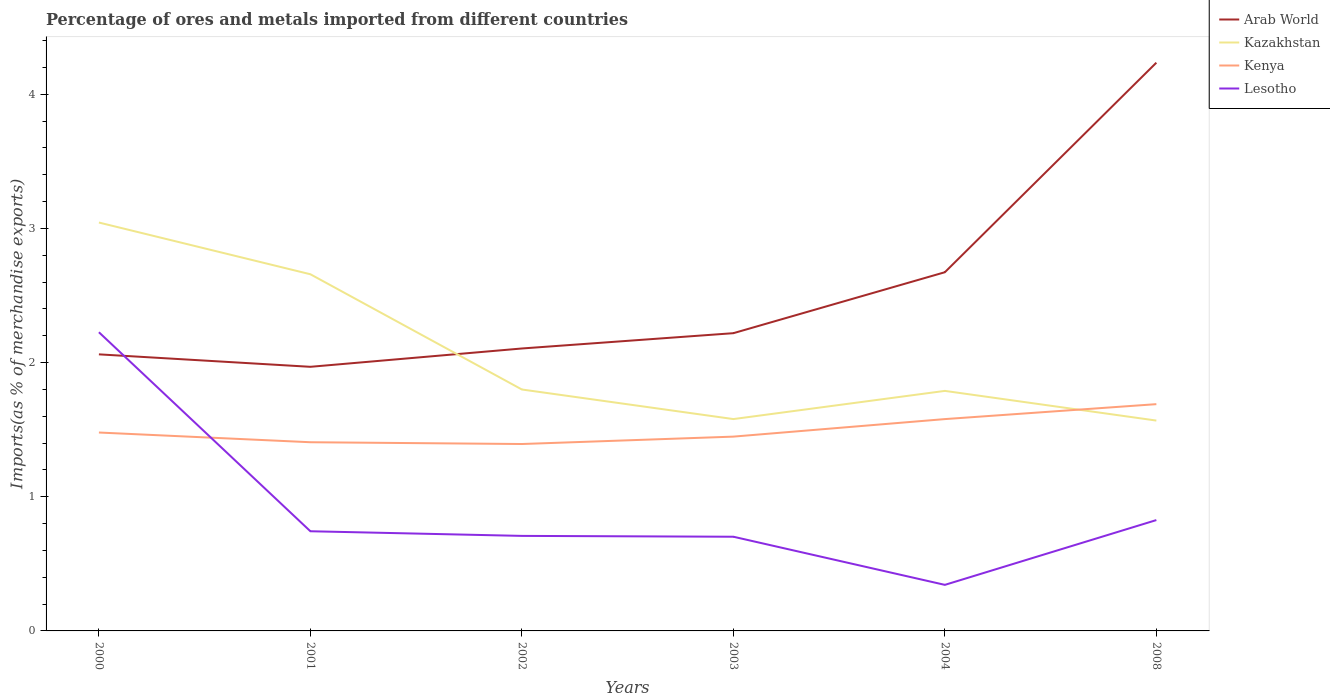Is the number of lines equal to the number of legend labels?
Give a very brief answer. Yes. Across all years, what is the maximum percentage of imports to different countries in Lesotho?
Provide a succinct answer. 0.34. In which year was the percentage of imports to different countries in Lesotho maximum?
Give a very brief answer. 2004. What is the total percentage of imports to different countries in Kazakhstan in the graph?
Make the answer very short. 1.47. What is the difference between the highest and the second highest percentage of imports to different countries in Arab World?
Your response must be concise. 2.27. How many years are there in the graph?
Keep it short and to the point. 6. Does the graph contain any zero values?
Ensure brevity in your answer.  No. Does the graph contain grids?
Ensure brevity in your answer.  No. Where does the legend appear in the graph?
Provide a short and direct response. Top right. How many legend labels are there?
Ensure brevity in your answer.  4. How are the legend labels stacked?
Offer a very short reply. Vertical. What is the title of the graph?
Provide a short and direct response. Percentage of ores and metals imported from different countries. Does "Madagascar" appear as one of the legend labels in the graph?
Keep it short and to the point. No. What is the label or title of the Y-axis?
Give a very brief answer. Imports(as % of merchandise exports). What is the Imports(as % of merchandise exports) of Arab World in 2000?
Give a very brief answer. 2.06. What is the Imports(as % of merchandise exports) of Kazakhstan in 2000?
Offer a very short reply. 3.04. What is the Imports(as % of merchandise exports) of Kenya in 2000?
Provide a short and direct response. 1.48. What is the Imports(as % of merchandise exports) in Lesotho in 2000?
Your response must be concise. 2.23. What is the Imports(as % of merchandise exports) of Arab World in 2001?
Ensure brevity in your answer.  1.97. What is the Imports(as % of merchandise exports) in Kazakhstan in 2001?
Your response must be concise. 2.66. What is the Imports(as % of merchandise exports) in Kenya in 2001?
Keep it short and to the point. 1.41. What is the Imports(as % of merchandise exports) of Lesotho in 2001?
Keep it short and to the point. 0.74. What is the Imports(as % of merchandise exports) of Arab World in 2002?
Keep it short and to the point. 2.11. What is the Imports(as % of merchandise exports) in Kazakhstan in 2002?
Your answer should be very brief. 1.8. What is the Imports(as % of merchandise exports) of Kenya in 2002?
Provide a succinct answer. 1.39. What is the Imports(as % of merchandise exports) of Lesotho in 2002?
Your answer should be very brief. 0.71. What is the Imports(as % of merchandise exports) of Arab World in 2003?
Keep it short and to the point. 2.22. What is the Imports(as % of merchandise exports) in Kazakhstan in 2003?
Your answer should be compact. 1.58. What is the Imports(as % of merchandise exports) of Kenya in 2003?
Make the answer very short. 1.45. What is the Imports(as % of merchandise exports) in Lesotho in 2003?
Ensure brevity in your answer.  0.7. What is the Imports(as % of merchandise exports) in Arab World in 2004?
Provide a short and direct response. 2.67. What is the Imports(as % of merchandise exports) of Kazakhstan in 2004?
Offer a very short reply. 1.79. What is the Imports(as % of merchandise exports) of Kenya in 2004?
Your answer should be compact. 1.58. What is the Imports(as % of merchandise exports) of Lesotho in 2004?
Offer a terse response. 0.34. What is the Imports(as % of merchandise exports) of Arab World in 2008?
Offer a terse response. 4.24. What is the Imports(as % of merchandise exports) of Kazakhstan in 2008?
Offer a terse response. 1.57. What is the Imports(as % of merchandise exports) of Kenya in 2008?
Your answer should be compact. 1.69. What is the Imports(as % of merchandise exports) of Lesotho in 2008?
Ensure brevity in your answer.  0.83. Across all years, what is the maximum Imports(as % of merchandise exports) of Arab World?
Offer a terse response. 4.24. Across all years, what is the maximum Imports(as % of merchandise exports) in Kazakhstan?
Offer a very short reply. 3.04. Across all years, what is the maximum Imports(as % of merchandise exports) of Kenya?
Give a very brief answer. 1.69. Across all years, what is the maximum Imports(as % of merchandise exports) in Lesotho?
Your answer should be compact. 2.23. Across all years, what is the minimum Imports(as % of merchandise exports) of Arab World?
Offer a very short reply. 1.97. Across all years, what is the minimum Imports(as % of merchandise exports) in Kazakhstan?
Keep it short and to the point. 1.57. Across all years, what is the minimum Imports(as % of merchandise exports) in Kenya?
Your answer should be compact. 1.39. Across all years, what is the minimum Imports(as % of merchandise exports) in Lesotho?
Offer a very short reply. 0.34. What is the total Imports(as % of merchandise exports) of Arab World in the graph?
Give a very brief answer. 15.27. What is the total Imports(as % of merchandise exports) in Kazakhstan in the graph?
Your response must be concise. 12.44. What is the total Imports(as % of merchandise exports) in Kenya in the graph?
Provide a short and direct response. 9. What is the total Imports(as % of merchandise exports) in Lesotho in the graph?
Your response must be concise. 5.55. What is the difference between the Imports(as % of merchandise exports) of Arab World in 2000 and that in 2001?
Ensure brevity in your answer.  0.09. What is the difference between the Imports(as % of merchandise exports) in Kazakhstan in 2000 and that in 2001?
Keep it short and to the point. 0.39. What is the difference between the Imports(as % of merchandise exports) in Kenya in 2000 and that in 2001?
Offer a terse response. 0.07. What is the difference between the Imports(as % of merchandise exports) of Lesotho in 2000 and that in 2001?
Ensure brevity in your answer.  1.48. What is the difference between the Imports(as % of merchandise exports) in Arab World in 2000 and that in 2002?
Keep it short and to the point. -0.04. What is the difference between the Imports(as % of merchandise exports) in Kazakhstan in 2000 and that in 2002?
Make the answer very short. 1.24. What is the difference between the Imports(as % of merchandise exports) of Kenya in 2000 and that in 2002?
Offer a terse response. 0.09. What is the difference between the Imports(as % of merchandise exports) of Lesotho in 2000 and that in 2002?
Your response must be concise. 1.52. What is the difference between the Imports(as % of merchandise exports) in Arab World in 2000 and that in 2003?
Keep it short and to the point. -0.16. What is the difference between the Imports(as % of merchandise exports) in Kazakhstan in 2000 and that in 2003?
Your answer should be very brief. 1.47. What is the difference between the Imports(as % of merchandise exports) in Kenya in 2000 and that in 2003?
Provide a succinct answer. 0.03. What is the difference between the Imports(as % of merchandise exports) in Lesotho in 2000 and that in 2003?
Offer a very short reply. 1.52. What is the difference between the Imports(as % of merchandise exports) of Arab World in 2000 and that in 2004?
Make the answer very short. -0.61. What is the difference between the Imports(as % of merchandise exports) in Kazakhstan in 2000 and that in 2004?
Offer a very short reply. 1.25. What is the difference between the Imports(as % of merchandise exports) of Kenya in 2000 and that in 2004?
Make the answer very short. -0.1. What is the difference between the Imports(as % of merchandise exports) of Lesotho in 2000 and that in 2004?
Offer a terse response. 1.88. What is the difference between the Imports(as % of merchandise exports) of Arab World in 2000 and that in 2008?
Your answer should be very brief. -2.17. What is the difference between the Imports(as % of merchandise exports) of Kazakhstan in 2000 and that in 2008?
Your answer should be very brief. 1.48. What is the difference between the Imports(as % of merchandise exports) of Kenya in 2000 and that in 2008?
Your answer should be compact. -0.21. What is the difference between the Imports(as % of merchandise exports) in Lesotho in 2000 and that in 2008?
Provide a short and direct response. 1.4. What is the difference between the Imports(as % of merchandise exports) in Arab World in 2001 and that in 2002?
Make the answer very short. -0.14. What is the difference between the Imports(as % of merchandise exports) in Kazakhstan in 2001 and that in 2002?
Provide a short and direct response. 0.86. What is the difference between the Imports(as % of merchandise exports) in Kenya in 2001 and that in 2002?
Your answer should be compact. 0.01. What is the difference between the Imports(as % of merchandise exports) in Lesotho in 2001 and that in 2002?
Offer a terse response. 0.03. What is the difference between the Imports(as % of merchandise exports) of Arab World in 2001 and that in 2003?
Offer a very short reply. -0.25. What is the difference between the Imports(as % of merchandise exports) of Kazakhstan in 2001 and that in 2003?
Provide a succinct answer. 1.08. What is the difference between the Imports(as % of merchandise exports) of Kenya in 2001 and that in 2003?
Keep it short and to the point. -0.04. What is the difference between the Imports(as % of merchandise exports) of Lesotho in 2001 and that in 2003?
Keep it short and to the point. 0.04. What is the difference between the Imports(as % of merchandise exports) of Arab World in 2001 and that in 2004?
Provide a short and direct response. -0.71. What is the difference between the Imports(as % of merchandise exports) in Kazakhstan in 2001 and that in 2004?
Give a very brief answer. 0.87. What is the difference between the Imports(as % of merchandise exports) of Kenya in 2001 and that in 2004?
Your response must be concise. -0.17. What is the difference between the Imports(as % of merchandise exports) in Lesotho in 2001 and that in 2004?
Your answer should be compact. 0.4. What is the difference between the Imports(as % of merchandise exports) of Arab World in 2001 and that in 2008?
Your answer should be compact. -2.27. What is the difference between the Imports(as % of merchandise exports) in Kazakhstan in 2001 and that in 2008?
Provide a short and direct response. 1.09. What is the difference between the Imports(as % of merchandise exports) in Kenya in 2001 and that in 2008?
Give a very brief answer. -0.28. What is the difference between the Imports(as % of merchandise exports) of Lesotho in 2001 and that in 2008?
Your answer should be compact. -0.08. What is the difference between the Imports(as % of merchandise exports) in Arab World in 2002 and that in 2003?
Your response must be concise. -0.11. What is the difference between the Imports(as % of merchandise exports) of Kazakhstan in 2002 and that in 2003?
Provide a succinct answer. 0.22. What is the difference between the Imports(as % of merchandise exports) in Kenya in 2002 and that in 2003?
Your answer should be compact. -0.06. What is the difference between the Imports(as % of merchandise exports) of Lesotho in 2002 and that in 2003?
Offer a terse response. 0.01. What is the difference between the Imports(as % of merchandise exports) of Arab World in 2002 and that in 2004?
Offer a very short reply. -0.57. What is the difference between the Imports(as % of merchandise exports) of Kazakhstan in 2002 and that in 2004?
Provide a succinct answer. 0.01. What is the difference between the Imports(as % of merchandise exports) of Kenya in 2002 and that in 2004?
Provide a short and direct response. -0.19. What is the difference between the Imports(as % of merchandise exports) of Lesotho in 2002 and that in 2004?
Provide a short and direct response. 0.36. What is the difference between the Imports(as % of merchandise exports) of Arab World in 2002 and that in 2008?
Your response must be concise. -2.13. What is the difference between the Imports(as % of merchandise exports) in Kazakhstan in 2002 and that in 2008?
Make the answer very short. 0.23. What is the difference between the Imports(as % of merchandise exports) in Kenya in 2002 and that in 2008?
Your answer should be very brief. -0.3. What is the difference between the Imports(as % of merchandise exports) in Lesotho in 2002 and that in 2008?
Keep it short and to the point. -0.12. What is the difference between the Imports(as % of merchandise exports) in Arab World in 2003 and that in 2004?
Your answer should be very brief. -0.45. What is the difference between the Imports(as % of merchandise exports) in Kazakhstan in 2003 and that in 2004?
Ensure brevity in your answer.  -0.21. What is the difference between the Imports(as % of merchandise exports) of Kenya in 2003 and that in 2004?
Ensure brevity in your answer.  -0.13. What is the difference between the Imports(as % of merchandise exports) of Lesotho in 2003 and that in 2004?
Provide a succinct answer. 0.36. What is the difference between the Imports(as % of merchandise exports) in Arab World in 2003 and that in 2008?
Your answer should be very brief. -2.02. What is the difference between the Imports(as % of merchandise exports) in Kazakhstan in 2003 and that in 2008?
Offer a terse response. 0.01. What is the difference between the Imports(as % of merchandise exports) of Kenya in 2003 and that in 2008?
Your response must be concise. -0.24. What is the difference between the Imports(as % of merchandise exports) of Lesotho in 2003 and that in 2008?
Offer a terse response. -0.12. What is the difference between the Imports(as % of merchandise exports) in Arab World in 2004 and that in 2008?
Keep it short and to the point. -1.56. What is the difference between the Imports(as % of merchandise exports) in Kazakhstan in 2004 and that in 2008?
Provide a succinct answer. 0.22. What is the difference between the Imports(as % of merchandise exports) of Kenya in 2004 and that in 2008?
Offer a very short reply. -0.11. What is the difference between the Imports(as % of merchandise exports) in Lesotho in 2004 and that in 2008?
Your answer should be compact. -0.48. What is the difference between the Imports(as % of merchandise exports) of Arab World in 2000 and the Imports(as % of merchandise exports) of Kazakhstan in 2001?
Offer a terse response. -0.6. What is the difference between the Imports(as % of merchandise exports) of Arab World in 2000 and the Imports(as % of merchandise exports) of Kenya in 2001?
Offer a terse response. 0.66. What is the difference between the Imports(as % of merchandise exports) in Arab World in 2000 and the Imports(as % of merchandise exports) in Lesotho in 2001?
Offer a very short reply. 1.32. What is the difference between the Imports(as % of merchandise exports) in Kazakhstan in 2000 and the Imports(as % of merchandise exports) in Kenya in 2001?
Ensure brevity in your answer.  1.64. What is the difference between the Imports(as % of merchandise exports) of Kazakhstan in 2000 and the Imports(as % of merchandise exports) of Lesotho in 2001?
Your answer should be very brief. 2.3. What is the difference between the Imports(as % of merchandise exports) in Kenya in 2000 and the Imports(as % of merchandise exports) in Lesotho in 2001?
Make the answer very short. 0.74. What is the difference between the Imports(as % of merchandise exports) of Arab World in 2000 and the Imports(as % of merchandise exports) of Kazakhstan in 2002?
Offer a terse response. 0.26. What is the difference between the Imports(as % of merchandise exports) of Arab World in 2000 and the Imports(as % of merchandise exports) of Kenya in 2002?
Offer a very short reply. 0.67. What is the difference between the Imports(as % of merchandise exports) of Arab World in 2000 and the Imports(as % of merchandise exports) of Lesotho in 2002?
Make the answer very short. 1.35. What is the difference between the Imports(as % of merchandise exports) of Kazakhstan in 2000 and the Imports(as % of merchandise exports) of Kenya in 2002?
Your answer should be compact. 1.65. What is the difference between the Imports(as % of merchandise exports) of Kazakhstan in 2000 and the Imports(as % of merchandise exports) of Lesotho in 2002?
Give a very brief answer. 2.34. What is the difference between the Imports(as % of merchandise exports) in Kenya in 2000 and the Imports(as % of merchandise exports) in Lesotho in 2002?
Offer a very short reply. 0.77. What is the difference between the Imports(as % of merchandise exports) of Arab World in 2000 and the Imports(as % of merchandise exports) of Kazakhstan in 2003?
Offer a very short reply. 0.48. What is the difference between the Imports(as % of merchandise exports) in Arab World in 2000 and the Imports(as % of merchandise exports) in Kenya in 2003?
Make the answer very short. 0.61. What is the difference between the Imports(as % of merchandise exports) in Arab World in 2000 and the Imports(as % of merchandise exports) in Lesotho in 2003?
Provide a short and direct response. 1.36. What is the difference between the Imports(as % of merchandise exports) in Kazakhstan in 2000 and the Imports(as % of merchandise exports) in Kenya in 2003?
Your answer should be very brief. 1.6. What is the difference between the Imports(as % of merchandise exports) of Kazakhstan in 2000 and the Imports(as % of merchandise exports) of Lesotho in 2003?
Your response must be concise. 2.34. What is the difference between the Imports(as % of merchandise exports) of Kenya in 2000 and the Imports(as % of merchandise exports) of Lesotho in 2003?
Offer a terse response. 0.78. What is the difference between the Imports(as % of merchandise exports) of Arab World in 2000 and the Imports(as % of merchandise exports) of Kazakhstan in 2004?
Your response must be concise. 0.27. What is the difference between the Imports(as % of merchandise exports) in Arab World in 2000 and the Imports(as % of merchandise exports) in Kenya in 2004?
Offer a terse response. 0.48. What is the difference between the Imports(as % of merchandise exports) of Arab World in 2000 and the Imports(as % of merchandise exports) of Lesotho in 2004?
Offer a terse response. 1.72. What is the difference between the Imports(as % of merchandise exports) in Kazakhstan in 2000 and the Imports(as % of merchandise exports) in Kenya in 2004?
Your answer should be very brief. 1.47. What is the difference between the Imports(as % of merchandise exports) in Kazakhstan in 2000 and the Imports(as % of merchandise exports) in Lesotho in 2004?
Offer a very short reply. 2.7. What is the difference between the Imports(as % of merchandise exports) of Kenya in 2000 and the Imports(as % of merchandise exports) of Lesotho in 2004?
Offer a very short reply. 1.14. What is the difference between the Imports(as % of merchandise exports) of Arab World in 2000 and the Imports(as % of merchandise exports) of Kazakhstan in 2008?
Ensure brevity in your answer.  0.49. What is the difference between the Imports(as % of merchandise exports) in Arab World in 2000 and the Imports(as % of merchandise exports) in Kenya in 2008?
Ensure brevity in your answer.  0.37. What is the difference between the Imports(as % of merchandise exports) of Arab World in 2000 and the Imports(as % of merchandise exports) of Lesotho in 2008?
Make the answer very short. 1.24. What is the difference between the Imports(as % of merchandise exports) of Kazakhstan in 2000 and the Imports(as % of merchandise exports) of Kenya in 2008?
Your response must be concise. 1.35. What is the difference between the Imports(as % of merchandise exports) of Kazakhstan in 2000 and the Imports(as % of merchandise exports) of Lesotho in 2008?
Your response must be concise. 2.22. What is the difference between the Imports(as % of merchandise exports) in Kenya in 2000 and the Imports(as % of merchandise exports) in Lesotho in 2008?
Give a very brief answer. 0.65. What is the difference between the Imports(as % of merchandise exports) in Arab World in 2001 and the Imports(as % of merchandise exports) in Kazakhstan in 2002?
Provide a succinct answer. 0.17. What is the difference between the Imports(as % of merchandise exports) in Arab World in 2001 and the Imports(as % of merchandise exports) in Kenya in 2002?
Your answer should be very brief. 0.58. What is the difference between the Imports(as % of merchandise exports) in Arab World in 2001 and the Imports(as % of merchandise exports) in Lesotho in 2002?
Keep it short and to the point. 1.26. What is the difference between the Imports(as % of merchandise exports) in Kazakhstan in 2001 and the Imports(as % of merchandise exports) in Kenya in 2002?
Give a very brief answer. 1.27. What is the difference between the Imports(as % of merchandise exports) in Kazakhstan in 2001 and the Imports(as % of merchandise exports) in Lesotho in 2002?
Provide a succinct answer. 1.95. What is the difference between the Imports(as % of merchandise exports) of Kenya in 2001 and the Imports(as % of merchandise exports) of Lesotho in 2002?
Offer a very short reply. 0.7. What is the difference between the Imports(as % of merchandise exports) in Arab World in 2001 and the Imports(as % of merchandise exports) in Kazakhstan in 2003?
Keep it short and to the point. 0.39. What is the difference between the Imports(as % of merchandise exports) in Arab World in 2001 and the Imports(as % of merchandise exports) in Kenya in 2003?
Offer a terse response. 0.52. What is the difference between the Imports(as % of merchandise exports) in Arab World in 2001 and the Imports(as % of merchandise exports) in Lesotho in 2003?
Offer a terse response. 1.27. What is the difference between the Imports(as % of merchandise exports) of Kazakhstan in 2001 and the Imports(as % of merchandise exports) of Kenya in 2003?
Ensure brevity in your answer.  1.21. What is the difference between the Imports(as % of merchandise exports) in Kazakhstan in 2001 and the Imports(as % of merchandise exports) in Lesotho in 2003?
Your answer should be very brief. 1.96. What is the difference between the Imports(as % of merchandise exports) in Kenya in 2001 and the Imports(as % of merchandise exports) in Lesotho in 2003?
Ensure brevity in your answer.  0.7. What is the difference between the Imports(as % of merchandise exports) of Arab World in 2001 and the Imports(as % of merchandise exports) of Kazakhstan in 2004?
Provide a short and direct response. 0.18. What is the difference between the Imports(as % of merchandise exports) of Arab World in 2001 and the Imports(as % of merchandise exports) of Kenya in 2004?
Offer a terse response. 0.39. What is the difference between the Imports(as % of merchandise exports) of Arab World in 2001 and the Imports(as % of merchandise exports) of Lesotho in 2004?
Offer a terse response. 1.63. What is the difference between the Imports(as % of merchandise exports) in Kazakhstan in 2001 and the Imports(as % of merchandise exports) in Kenya in 2004?
Provide a short and direct response. 1.08. What is the difference between the Imports(as % of merchandise exports) in Kazakhstan in 2001 and the Imports(as % of merchandise exports) in Lesotho in 2004?
Your answer should be compact. 2.32. What is the difference between the Imports(as % of merchandise exports) in Kenya in 2001 and the Imports(as % of merchandise exports) in Lesotho in 2004?
Give a very brief answer. 1.06. What is the difference between the Imports(as % of merchandise exports) of Arab World in 2001 and the Imports(as % of merchandise exports) of Kazakhstan in 2008?
Keep it short and to the point. 0.4. What is the difference between the Imports(as % of merchandise exports) of Arab World in 2001 and the Imports(as % of merchandise exports) of Kenya in 2008?
Keep it short and to the point. 0.28. What is the difference between the Imports(as % of merchandise exports) of Arab World in 2001 and the Imports(as % of merchandise exports) of Lesotho in 2008?
Provide a succinct answer. 1.14. What is the difference between the Imports(as % of merchandise exports) of Kazakhstan in 2001 and the Imports(as % of merchandise exports) of Kenya in 2008?
Give a very brief answer. 0.97. What is the difference between the Imports(as % of merchandise exports) in Kazakhstan in 2001 and the Imports(as % of merchandise exports) in Lesotho in 2008?
Your response must be concise. 1.83. What is the difference between the Imports(as % of merchandise exports) of Kenya in 2001 and the Imports(as % of merchandise exports) of Lesotho in 2008?
Provide a short and direct response. 0.58. What is the difference between the Imports(as % of merchandise exports) in Arab World in 2002 and the Imports(as % of merchandise exports) in Kazakhstan in 2003?
Your response must be concise. 0.53. What is the difference between the Imports(as % of merchandise exports) of Arab World in 2002 and the Imports(as % of merchandise exports) of Kenya in 2003?
Make the answer very short. 0.66. What is the difference between the Imports(as % of merchandise exports) of Arab World in 2002 and the Imports(as % of merchandise exports) of Lesotho in 2003?
Make the answer very short. 1.4. What is the difference between the Imports(as % of merchandise exports) in Kazakhstan in 2002 and the Imports(as % of merchandise exports) in Kenya in 2003?
Your response must be concise. 0.35. What is the difference between the Imports(as % of merchandise exports) of Kazakhstan in 2002 and the Imports(as % of merchandise exports) of Lesotho in 2003?
Your answer should be compact. 1.1. What is the difference between the Imports(as % of merchandise exports) in Kenya in 2002 and the Imports(as % of merchandise exports) in Lesotho in 2003?
Provide a succinct answer. 0.69. What is the difference between the Imports(as % of merchandise exports) of Arab World in 2002 and the Imports(as % of merchandise exports) of Kazakhstan in 2004?
Provide a succinct answer. 0.32. What is the difference between the Imports(as % of merchandise exports) in Arab World in 2002 and the Imports(as % of merchandise exports) in Kenya in 2004?
Keep it short and to the point. 0.53. What is the difference between the Imports(as % of merchandise exports) of Arab World in 2002 and the Imports(as % of merchandise exports) of Lesotho in 2004?
Offer a terse response. 1.76. What is the difference between the Imports(as % of merchandise exports) in Kazakhstan in 2002 and the Imports(as % of merchandise exports) in Kenya in 2004?
Ensure brevity in your answer.  0.22. What is the difference between the Imports(as % of merchandise exports) of Kazakhstan in 2002 and the Imports(as % of merchandise exports) of Lesotho in 2004?
Offer a terse response. 1.46. What is the difference between the Imports(as % of merchandise exports) of Arab World in 2002 and the Imports(as % of merchandise exports) of Kazakhstan in 2008?
Make the answer very short. 0.54. What is the difference between the Imports(as % of merchandise exports) of Arab World in 2002 and the Imports(as % of merchandise exports) of Kenya in 2008?
Provide a short and direct response. 0.41. What is the difference between the Imports(as % of merchandise exports) in Arab World in 2002 and the Imports(as % of merchandise exports) in Lesotho in 2008?
Make the answer very short. 1.28. What is the difference between the Imports(as % of merchandise exports) of Kazakhstan in 2002 and the Imports(as % of merchandise exports) of Kenya in 2008?
Provide a short and direct response. 0.11. What is the difference between the Imports(as % of merchandise exports) in Kazakhstan in 2002 and the Imports(as % of merchandise exports) in Lesotho in 2008?
Make the answer very short. 0.97. What is the difference between the Imports(as % of merchandise exports) in Kenya in 2002 and the Imports(as % of merchandise exports) in Lesotho in 2008?
Keep it short and to the point. 0.57. What is the difference between the Imports(as % of merchandise exports) in Arab World in 2003 and the Imports(as % of merchandise exports) in Kazakhstan in 2004?
Offer a very short reply. 0.43. What is the difference between the Imports(as % of merchandise exports) of Arab World in 2003 and the Imports(as % of merchandise exports) of Kenya in 2004?
Make the answer very short. 0.64. What is the difference between the Imports(as % of merchandise exports) of Arab World in 2003 and the Imports(as % of merchandise exports) of Lesotho in 2004?
Give a very brief answer. 1.88. What is the difference between the Imports(as % of merchandise exports) in Kazakhstan in 2003 and the Imports(as % of merchandise exports) in Kenya in 2004?
Give a very brief answer. 0. What is the difference between the Imports(as % of merchandise exports) in Kazakhstan in 2003 and the Imports(as % of merchandise exports) in Lesotho in 2004?
Keep it short and to the point. 1.24. What is the difference between the Imports(as % of merchandise exports) in Kenya in 2003 and the Imports(as % of merchandise exports) in Lesotho in 2004?
Provide a short and direct response. 1.11. What is the difference between the Imports(as % of merchandise exports) of Arab World in 2003 and the Imports(as % of merchandise exports) of Kazakhstan in 2008?
Offer a very short reply. 0.65. What is the difference between the Imports(as % of merchandise exports) in Arab World in 2003 and the Imports(as % of merchandise exports) in Kenya in 2008?
Your answer should be very brief. 0.53. What is the difference between the Imports(as % of merchandise exports) of Arab World in 2003 and the Imports(as % of merchandise exports) of Lesotho in 2008?
Ensure brevity in your answer.  1.39. What is the difference between the Imports(as % of merchandise exports) in Kazakhstan in 2003 and the Imports(as % of merchandise exports) in Kenya in 2008?
Offer a terse response. -0.11. What is the difference between the Imports(as % of merchandise exports) in Kazakhstan in 2003 and the Imports(as % of merchandise exports) in Lesotho in 2008?
Provide a succinct answer. 0.75. What is the difference between the Imports(as % of merchandise exports) of Kenya in 2003 and the Imports(as % of merchandise exports) of Lesotho in 2008?
Your answer should be compact. 0.62. What is the difference between the Imports(as % of merchandise exports) of Arab World in 2004 and the Imports(as % of merchandise exports) of Kazakhstan in 2008?
Provide a short and direct response. 1.11. What is the difference between the Imports(as % of merchandise exports) in Arab World in 2004 and the Imports(as % of merchandise exports) in Kenya in 2008?
Provide a short and direct response. 0.98. What is the difference between the Imports(as % of merchandise exports) in Arab World in 2004 and the Imports(as % of merchandise exports) in Lesotho in 2008?
Provide a short and direct response. 1.85. What is the difference between the Imports(as % of merchandise exports) of Kazakhstan in 2004 and the Imports(as % of merchandise exports) of Kenya in 2008?
Provide a succinct answer. 0.1. What is the difference between the Imports(as % of merchandise exports) in Kenya in 2004 and the Imports(as % of merchandise exports) in Lesotho in 2008?
Ensure brevity in your answer.  0.75. What is the average Imports(as % of merchandise exports) of Arab World per year?
Your answer should be very brief. 2.54. What is the average Imports(as % of merchandise exports) of Kazakhstan per year?
Offer a very short reply. 2.07. What is the average Imports(as % of merchandise exports) in Kenya per year?
Ensure brevity in your answer.  1.5. What is the average Imports(as % of merchandise exports) in Lesotho per year?
Your answer should be very brief. 0.92. In the year 2000, what is the difference between the Imports(as % of merchandise exports) in Arab World and Imports(as % of merchandise exports) in Kazakhstan?
Your answer should be very brief. -0.98. In the year 2000, what is the difference between the Imports(as % of merchandise exports) of Arab World and Imports(as % of merchandise exports) of Kenya?
Offer a very short reply. 0.58. In the year 2000, what is the difference between the Imports(as % of merchandise exports) of Arab World and Imports(as % of merchandise exports) of Lesotho?
Make the answer very short. -0.16. In the year 2000, what is the difference between the Imports(as % of merchandise exports) of Kazakhstan and Imports(as % of merchandise exports) of Kenya?
Keep it short and to the point. 1.57. In the year 2000, what is the difference between the Imports(as % of merchandise exports) in Kazakhstan and Imports(as % of merchandise exports) in Lesotho?
Your answer should be compact. 0.82. In the year 2000, what is the difference between the Imports(as % of merchandise exports) in Kenya and Imports(as % of merchandise exports) in Lesotho?
Give a very brief answer. -0.75. In the year 2001, what is the difference between the Imports(as % of merchandise exports) in Arab World and Imports(as % of merchandise exports) in Kazakhstan?
Make the answer very short. -0.69. In the year 2001, what is the difference between the Imports(as % of merchandise exports) in Arab World and Imports(as % of merchandise exports) in Kenya?
Provide a short and direct response. 0.56. In the year 2001, what is the difference between the Imports(as % of merchandise exports) of Arab World and Imports(as % of merchandise exports) of Lesotho?
Ensure brevity in your answer.  1.23. In the year 2001, what is the difference between the Imports(as % of merchandise exports) of Kazakhstan and Imports(as % of merchandise exports) of Kenya?
Offer a terse response. 1.25. In the year 2001, what is the difference between the Imports(as % of merchandise exports) of Kazakhstan and Imports(as % of merchandise exports) of Lesotho?
Ensure brevity in your answer.  1.92. In the year 2001, what is the difference between the Imports(as % of merchandise exports) in Kenya and Imports(as % of merchandise exports) in Lesotho?
Offer a terse response. 0.66. In the year 2002, what is the difference between the Imports(as % of merchandise exports) of Arab World and Imports(as % of merchandise exports) of Kazakhstan?
Your answer should be compact. 0.31. In the year 2002, what is the difference between the Imports(as % of merchandise exports) in Arab World and Imports(as % of merchandise exports) in Kenya?
Keep it short and to the point. 0.71. In the year 2002, what is the difference between the Imports(as % of merchandise exports) of Arab World and Imports(as % of merchandise exports) of Lesotho?
Give a very brief answer. 1.4. In the year 2002, what is the difference between the Imports(as % of merchandise exports) in Kazakhstan and Imports(as % of merchandise exports) in Kenya?
Keep it short and to the point. 0.41. In the year 2002, what is the difference between the Imports(as % of merchandise exports) of Kazakhstan and Imports(as % of merchandise exports) of Lesotho?
Provide a succinct answer. 1.09. In the year 2002, what is the difference between the Imports(as % of merchandise exports) of Kenya and Imports(as % of merchandise exports) of Lesotho?
Provide a succinct answer. 0.68. In the year 2003, what is the difference between the Imports(as % of merchandise exports) of Arab World and Imports(as % of merchandise exports) of Kazakhstan?
Your answer should be compact. 0.64. In the year 2003, what is the difference between the Imports(as % of merchandise exports) of Arab World and Imports(as % of merchandise exports) of Kenya?
Offer a very short reply. 0.77. In the year 2003, what is the difference between the Imports(as % of merchandise exports) of Arab World and Imports(as % of merchandise exports) of Lesotho?
Give a very brief answer. 1.52. In the year 2003, what is the difference between the Imports(as % of merchandise exports) in Kazakhstan and Imports(as % of merchandise exports) in Kenya?
Your answer should be compact. 0.13. In the year 2003, what is the difference between the Imports(as % of merchandise exports) in Kazakhstan and Imports(as % of merchandise exports) in Lesotho?
Your answer should be very brief. 0.88. In the year 2003, what is the difference between the Imports(as % of merchandise exports) in Kenya and Imports(as % of merchandise exports) in Lesotho?
Your answer should be very brief. 0.75. In the year 2004, what is the difference between the Imports(as % of merchandise exports) of Arab World and Imports(as % of merchandise exports) of Kazakhstan?
Your answer should be very brief. 0.88. In the year 2004, what is the difference between the Imports(as % of merchandise exports) in Arab World and Imports(as % of merchandise exports) in Kenya?
Provide a succinct answer. 1.09. In the year 2004, what is the difference between the Imports(as % of merchandise exports) of Arab World and Imports(as % of merchandise exports) of Lesotho?
Your response must be concise. 2.33. In the year 2004, what is the difference between the Imports(as % of merchandise exports) in Kazakhstan and Imports(as % of merchandise exports) in Kenya?
Offer a terse response. 0.21. In the year 2004, what is the difference between the Imports(as % of merchandise exports) in Kazakhstan and Imports(as % of merchandise exports) in Lesotho?
Ensure brevity in your answer.  1.45. In the year 2004, what is the difference between the Imports(as % of merchandise exports) of Kenya and Imports(as % of merchandise exports) of Lesotho?
Ensure brevity in your answer.  1.24. In the year 2008, what is the difference between the Imports(as % of merchandise exports) in Arab World and Imports(as % of merchandise exports) in Kazakhstan?
Offer a very short reply. 2.67. In the year 2008, what is the difference between the Imports(as % of merchandise exports) in Arab World and Imports(as % of merchandise exports) in Kenya?
Keep it short and to the point. 2.55. In the year 2008, what is the difference between the Imports(as % of merchandise exports) of Arab World and Imports(as % of merchandise exports) of Lesotho?
Give a very brief answer. 3.41. In the year 2008, what is the difference between the Imports(as % of merchandise exports) of Kazakhstan and Imports(as % of merchandise exports) of Kenya?
Keep it short and to the point. -0.12. In the year 2008, what is the difference between the Imports(as % of merchandise exports) in Kazakhstan and Imports(as % of merchandise exports) in Lesotho?
Offer a terse response. 0.74. In the year 2008, what is the difference between the Imports(as % of merchandise exports) of Kenya and Imports(as % of merchandise exports) of Lesotho?
Give a very brief answer. 0.86. What is the ratio of the Imports(as % of merchandise exports) of Arab World in 2000 to that in 2001?
Make the answer very short. 1.05. What is the ratio of the Imports(as % of merchandise exports) of Kazakhstan in 2000 to that in 2001?
Give a very brief answer. 1.15. What is the ratio of the Imports(as % of merchandise exports) of Kenya in 2000 to that in 2001?
Make the answer very short. 1.05. What is the ratio of the Imports(as % of merchandise exports) in Lesotho in 2000 to that in 2001?
Your response must be concise. 3. What is the ratio of the Imports(as % of merchandise exports) of Arab World in 2000 to that in 2002?
Keep it short and to the point. 0.98. What is the ratio of the Imports(as % of merchandise exports) of Kazakhstan in 2000 to that in 2002?
Provide a succinct answer. 1.69. What is the ratio of the Imports(as % of merchandise exports) of Kenya in 2000 to that in 2002?
Offer a terse response. 1.06. What is the ratio of the Imports(as % of merchandise exports) in Lesotho in 2000 to that in 2002?
Give a very brief answer. 3.14. What is the ratio of the Imports(as % of merchandise exports) in Arab World in 2000 to that in 2003?
Ensure brevity in your answer.  0.93. What is the ratio of the Imports(as % of merchandise exports) of Kazakhstan in 2000 to that in 2003?
Your response must be concise. 1.93. What is the ratio of the Imports(as % of merchandise exports) in Kenya in 2000 to that in 2003?
Keep it short and to the point. 1.02. What is the ratio of the Imports(as % of merchandise exports) of Lesotho in 2000 to that in 2003?
Make the answer very short. 3.17. What is the ratio of the Imports(as % of merchandise exports) in Arab World in 2000 to that in 2004?
Provide a succinct answer. 0.77. What is the ratio of the Imports(as % of merchandise exports) in Kazakhstan in 2000 to that in 2004?
Make the answer very short. 1.7. What is the ratio of the Imports(as % of merchandise exports) of Kenya in 2000 to that in 2004?
Your response must be concise. 0.94. What is the ratio of the Imports(as % of merchandise exports) in Lesotho in 2000 to that in 2004?
Keep it short and to the point. 6.49. What is the ratio of the Imports(as % of merchandise exports) in Arab World in 2000 to that in 2008?
Provide a succinct answer. 0.49. What is the ratio of the Imports(as % of merchandise exports) in Kazakhstan in 2000 to that in 2008?
Give a very brief answer. 1.94. What is the ratio of the Imports(as % of merchandise exports) of Kenya in 2000 to that in 2008?
Your response must be concise. 0.87. What is the ratio of the Imports(as % of merchandise exports) in Lesotho in 2000 to that in 2008?
Give a very brief answer. 2.69. What is the ratio of the Imports(as % of merchandise exports) of Arab World in 2001 to that in 2002?
Offer a terse response. 0.94. What is the ratio of the Imports(as % of merchandise exports) in Kazakhstan in 2001 to that in 2002?
Give a very brief answer. 1.48. What is the ratio of the Imports(as % of merchandise exports) of Kenya in 2001 to that in 2002?
Keep it short and to the point. 1.01. What is the ratio of the Imports(as % of merchandise exports) of Lesotho in 2001 to that in 2002?
Ensure brevity in your answer.  1.05. What is the ratio of the Imports(as % of merchandise exports) in Arab World in 2001 to that in 2003?
Make the answer very short. 0.89. What is the ratio of the Imports(as % of merchandise exports) in Kazakhstan in 2001 to that in 2003?
Make the answer very short. 1.68. What is the ratio of the Imports(as % of merchandise exports) of Kenya in 2001 to that in 2003?
Provide a short and direct response. 0.97. What is the ratio of the Imports(as % of merchandise exports) in Lesotho in 2001 to that in 2003?
Your answer should be compact. 1.06. What is the ratio of the Imports(as % of merchandise exports) of Arab World in 2001 to that in 2004?
Provide a succinct answer. 0.74. What is the ratio of the Imports(as % of merchandise exports) in Kazakhstan in 2001 to that in 2004?
Provide a succinct answer. 1.49. What is the ratio of the Imports(as % of merchandise exports) of Kenya in 2001 to that in 2004?
Your response must be concise. 0.89. What is the ratio of the Imports(as % of merchandise exports) of Lesotho in 2001 to that in 2004?
Provide a succinct answer. 2.16. What is the ratio of the Imports(as % of merchandise exports) in Arab World in 2001 to that in 2008?
Your response must be concise. 0.46. What is the ratio of the Imports(as % of merchandise exports) of Kazakhstan in 2001 to that in 2008?
Keep it short and to the point. 1.7. What is the ratio of the Imports(as % of merchandise exports) of Kenya in 2001 to that in 2008?
Your response must be concise. 0.83. What is the ratio of the Imports(as % of merchandise exports) of Lesotho in 2001 to that in 2008?
Provide a short and direct response. 0.9. What is the ratio of the Imports(as % of merchandise exports) in Arab World in 2002 to that in 2003?
Provide a short and direct response. 0.95. What is the ratio of the Imports(as % of merchandise exports) in Kazakhstan in 2002 to that in 2003?
Your answer should be compact. 1.14. What is the ratio of the Imports(as % of merchandise exports) in Lesotho in 2002 to that in 2003?
Provide a succinct answer. 1.01. What is the ratio of the Imports(as % of merchandise exports) in Arab World in 2002 to that in 2004?
Offer a very short reply. 0.79. What is the ratio of the Imports(as % of merchandise exports) of Kenya in 2002 to that in 2004?
Ensure brevity in your answer.  0.88. What is the ratio of the Imports(as % of merchandise exports) of Lesotho in 2002 to that in 2004?
Ensure brevity in your answer.  2.06. What is the ratio of the Imports(as % of merchandise exports) in Arab World in 2002 to that in 2008?
Ensure brevity in your answer.  0.5. What is the ratio of the Imports(as % of merchandise exports) of Kazakhstan in 2002 to that in 2008?
Provide a succinct answer. 1.15. What is the ratio of the Imports(as % of merchandise exports) of Kenya in 2002 to that in 2008?
Make the answer very short. 0.82. What is the ratio of the Imports(as % of merchandise exports) of Lesotho in 2002 to that in 2008?
Offer a terse response. 0.86. What is the ratio of the Imports(as % of merchandise exports) of Arab World in 2003 to that in 2004?
Your response must be concise. 0.83. What is the ratio of the Imports(as % of merchandise exports) of Kazakhstan in 2003 to that in 2004?
Offer a very short reply. 0.88. What is the ratio of the Imports(as % of merchandise exports) in Kenya in 2003 to that in 2004?
Your answer should be very brief. 0.92. What is the ratio of the Imports(as % of merchandise exports) in Lesotho in 2003 to that in 2004?
Offer a terse response. 2.05. What is the ratio of the Imports(as % of merchandise exports) in Arab World in 2003 to that in 2008?
Your answer should be compact. 0.52. What is the ratio of the Imports(as % of merchandise exports) of Kazakhstan in 2003 to that in 2008?
Provide a short and direct response. 1.01. What is the ratio of the Imports(as % of merchandise exports) of Kenya in 2003 to that in 2008?
Provide a short and direct response. 0.86. What is the ratio of the Imports(as % of merchandise exports) in Lesotho in 2003 to that in 2008?
Keep it short and to the point. 0.85. What is the ratio of the Imports(as % of merchandise exports) in Arab World in 2004 to that in 2008?
Ensure brevity in your answer.  0.63. What is the ratio of the Imports(as % of merchandise exports) in Kazakhstan in 2004 to that in 2008?
Offer a very short reply. 1.14. What is the ratio of the Imports(as % of merchandise exports) of Kenya in 2004 to that in 2008?
Offer a terse response. 0.93. What is the ratio of the Imports(as % of merchandise exports) of Lesotho in 2004 to that in 2008?
Provide a short and direct response. 0.42. What is the difference between the highest and the second highest Imports(as % of merchandise exports) of Arab World?
Ensure brevity in your answer.  1.56. What is the difference between the highest and the second highest Imports(as % of merchandise exports) of Kazakhstan?
Provide a short and direct response. 0.39. What is the difference between the highest and the second highest Imports(as % of merchandise exports) in Kenya?
Make the answer very short. 0.11. What is the difference between the highest and the second highest Imports(as % of merchandise exports) in Lesotho?
Offer a very short reply. 1.4. What is the difference between the highest and the lowest Imports(as % of merchandise exports) in Arab World?
Your response must be concise. 2.27. What is the difference between the highest and the lowest Imports(as % of merchandise exports) of Kazakhstan?
Ensure brevity in your answer.  1.48. What is the difference between the highest and the lowest Imports(as % of merchandise exports) in Kenya?
Your answer should be compact. 0.3. What is the difference between the highest and the lowest Imports(as % of merchandise exports) in Lesotho?
Your response must be concise. 1.88. 